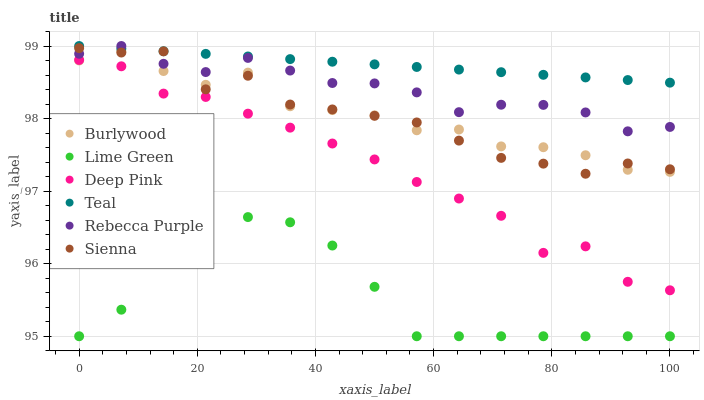Does Lime Green have the minimum area under the curve?
Answer yes or no. Yes. Does Teal have the maximum area under the curve?
Answer yes or no. Yes. Does Burlywood have the minimum area under the curve?
Answer yes or no. No. Does Burlywood have the maximum area under the curve?
Answer yes or no. No. Is Teal the smoothest?
Answer yes or no. Yes. Is Sienna the roughest?
Answer yes or no. Yes. Is Burlywood the smoothest?
Answer yes or no. No. Is Burlywood the roughest?
Answer yes or no. No. Does Lime Green have the lowest value?
Answer yes or no. Yes. Does Burlywood have the lowest value?
Answer yes or no. No. Does Teal have the highest value?
Answer yes or no. Yes. Does Burlywood have the highest value?
Answer yes or no. No. Is Deep Pink less than Teal?
Answer yes or no. Yes. Is Rebecca Purple greater than Burlywood?
Answer yes or no. Yes. Does Rebecca Purple intersect Teal?
Answer yes or no. Yes. Is Rebecca Purple less than Teal?
Answer yes or no. No. Is Rebecca Purple greater than Teal?
Answer yes or no. No. Does Deep Pink intersect Teal?
Answer yes or no. No. 